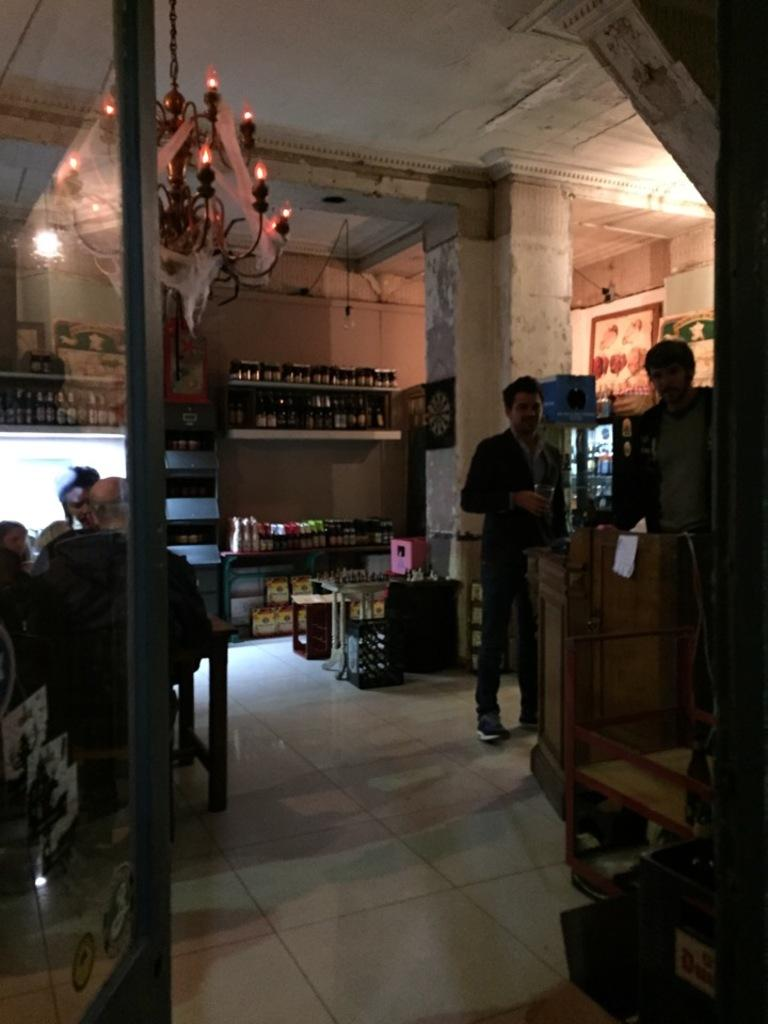Who or what is present in the image? There are people in the image. What can be seen in the background of the image? There are bottles on shelves in the background. Can you describe any lighting fixtures in the image? There is a light hanging down from the roof. What is located in the foreground of the image? There is a door in the foreground. Are there any yaks visible in the image? No, there are no yaks present in the image. Can you see any fairies flying around in the image? No, there are no fairies present in the image. 